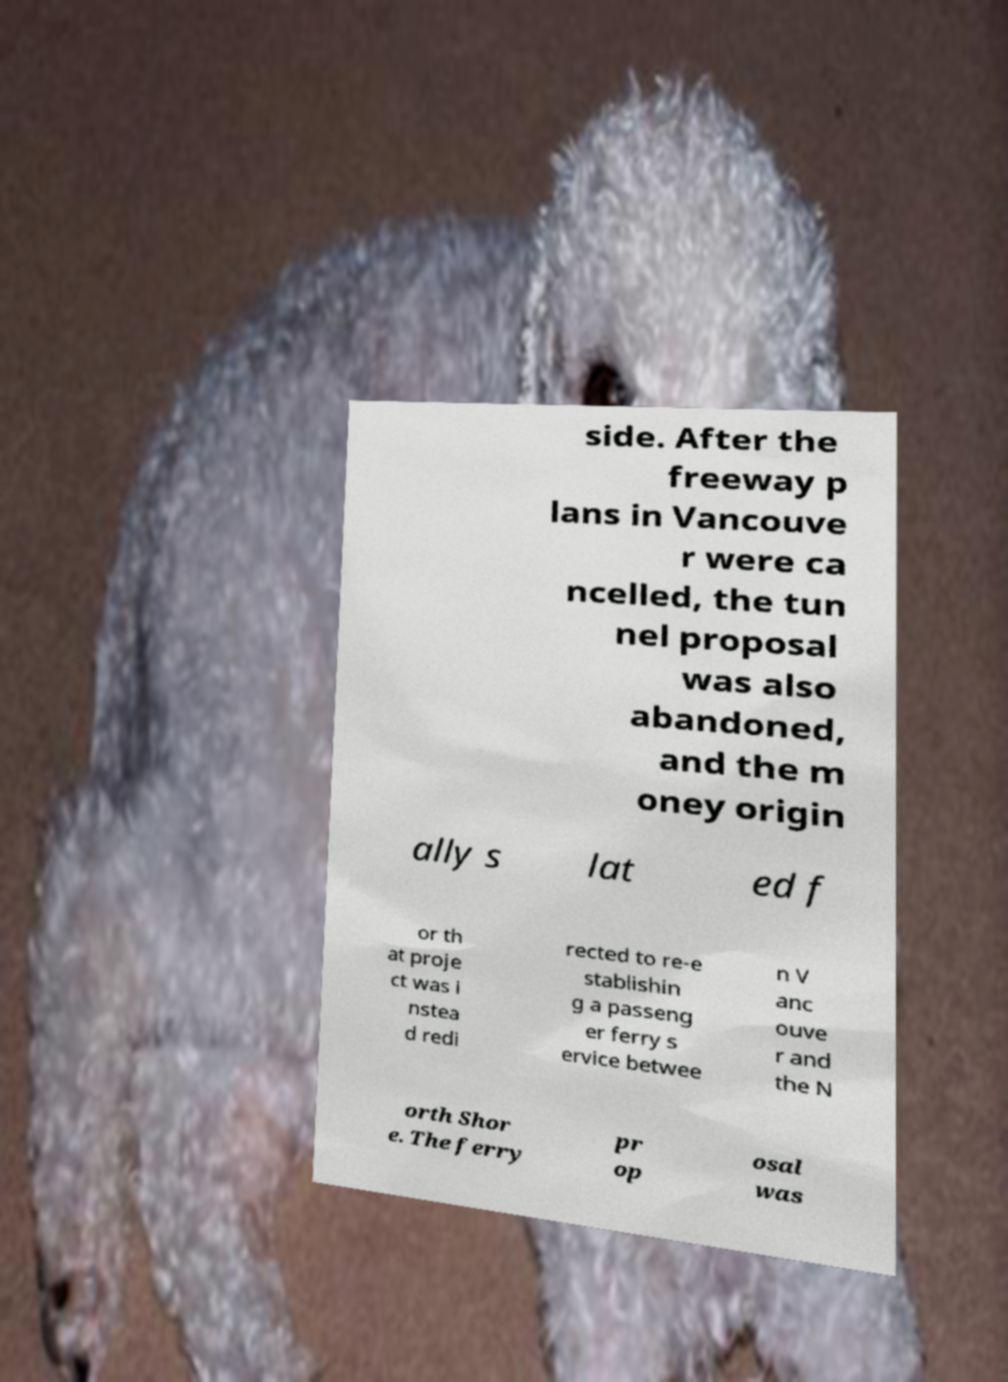What messages or text are displayed in this image? I need them in a readable, typed format. side. After the freeway p lans in Vancouve r were ca ncelled, the tun nel proposal was also abandoned, and the m oney origin ally s lat ed f or th at proje ct was i nstea d redi rected to re-e stablishin g a passeng er ferry s ervice betwee n V anc ouve r and the N orth Shor e. The ferry pr op osal was 